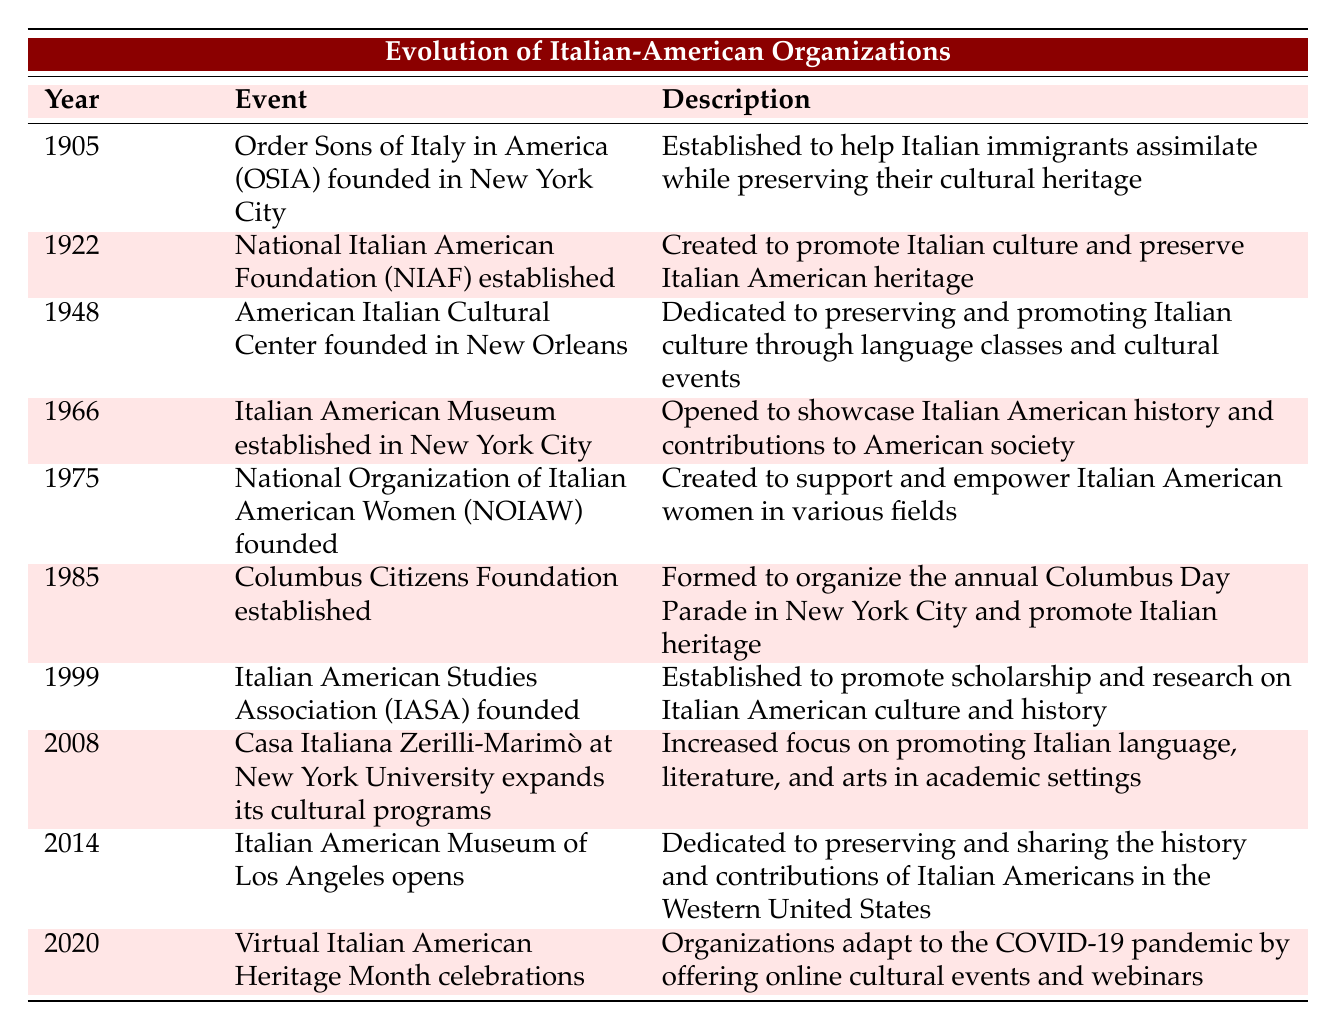What year was the Order Sons of Italy in America founded? The table indicates that the Order Sons of Italy in America was founded in the year 1905.
Answer: 1905 What is the primary focus of the National Italian American Foundation established in 1922? According to the table, the National Italian American Foundation was created to promote Italian culture and preserve Italian American heritage.
Answer: Promote Italian culture How many organizations focused on empowering or supporting women are listed before 2000? The table shows that there is one organization focused on empowering women before 2000, which is the National Organization of Italian American Women founded in 1975.
Answer: 1 Did the Italian American Museum open before the American Italian Cultural Center? By checking the dates in the table, the American Italian Cultural Center opened in 1948, while the Italian American Museum was established in 1966. Therefore, the American Italian Cultural Center opened earlier.
Answer: Yes What is the difference in years between the founding of the National Italian American Foundation and the establishment of the Italian American Studies Association? The National Italian American Foundation was established in 1922, and the Italian American Studies Association was founded in 1999. The difference in years is 1999 - 1922 = 77 years.
Answer: 77 